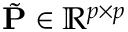<formula> <loc_0><loc_0><loc_500><loc_500>\tilde { P } \in \mathbb { R } ^ { p \times p }</formula> 